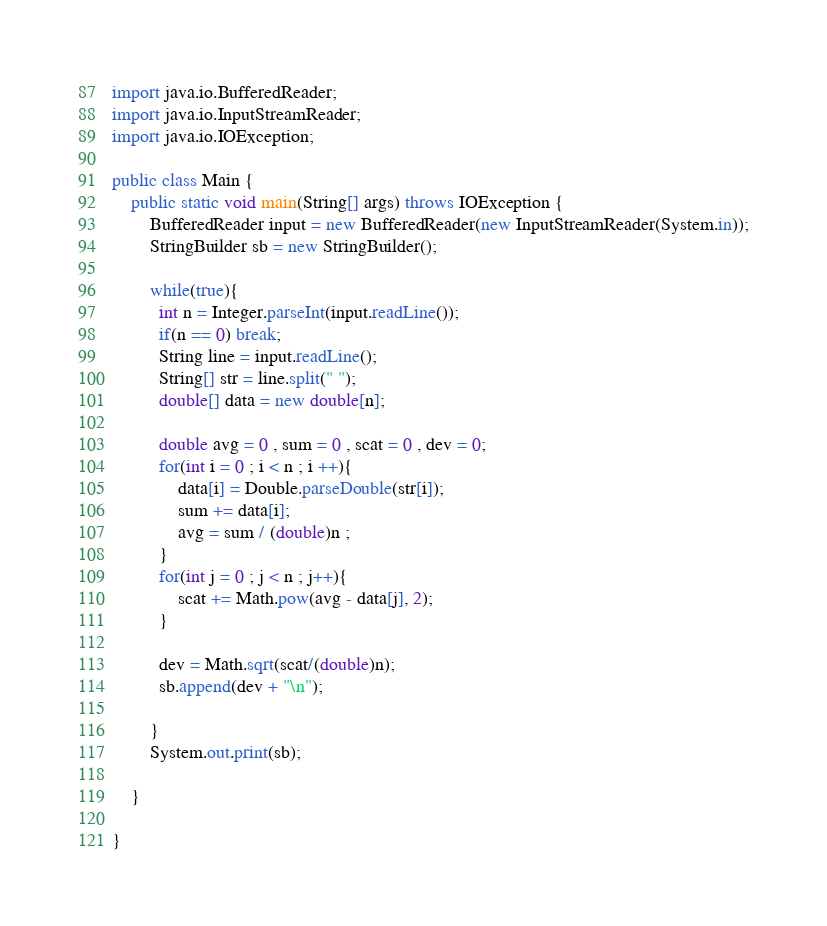Convert code to text. <code><loc_0><loc_0><loc_500><loc_500><_Java_>import java.io.BufferedReader;
import java.io.InputStreamReader;
import java.io.IOException;

public class Main {
	public static void main(String[] args) throws IOException {
		BufferedReader input = new BufferedReader(new InputStreamReader(System.in));
		StringBuilder sb = new StringBuilder();
		
		while(true){
		  int n = Integer.parseInt(input.readLine());
		  if(n == 0) break;
		  String line = input.readLine();
		  String[] str = line.split(" ");
		  double[] data = new double[n];
		  
		  double avg = 0 , sum = 0 , scat = 0 , dev = 0;
		  for(int i = 0 ; i < n ; i ++){
			  data[i] = Double.parseDouble(str[i]);
			  sum += data[i];
			  avg = sum / (double)n ;
		  }
		  for(int j = 0 ; j < n ; j++){
			  scat += Math.pow(avg - data[j], 2); 
		  }
		  
		  dev = Math.sqrt(scat/(double)n);
		  sb.append(dev + "\n");
		  
		}
		System.out.print(sb);
		
	}

}</code> 